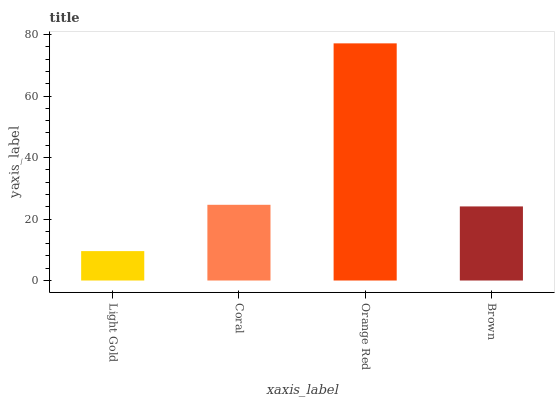Is Coral the minimum?
Answer yes or no. No. Is Coral the maximum?
Answer yes or no. No. Is Coral greater than Light Gold?
Answer yes or no. Yes. Is Light Gold less than Coral?
Answer yes or no. Yes. Is Light Gold greater than Coral?
Answer yes or no. No. Is Coral less than Light Gold?
Answer yes or no. No. Is Coral the high median?
Answer yes or no. Yes. Is Brown the low median?
Answer yes or no. Yes. Is Brown the high median?
Answer yes or no. No. Is Coral the low median?
Answer yes or no. No. 